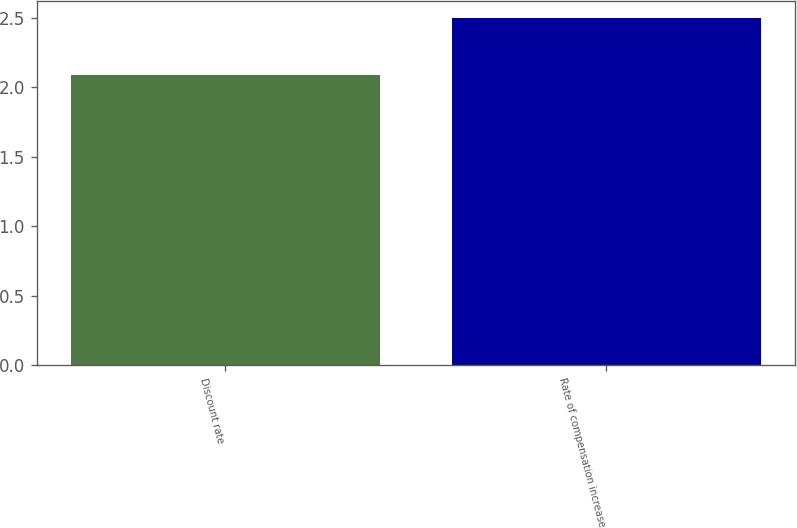<chart> <loc_0><loc_0><loc_500><loc_500><bar_chart><fcel>Discount rate<fcel>Rate of compensation increase<nl><fcel>2.09<fcel>2.5<nl></chart> 